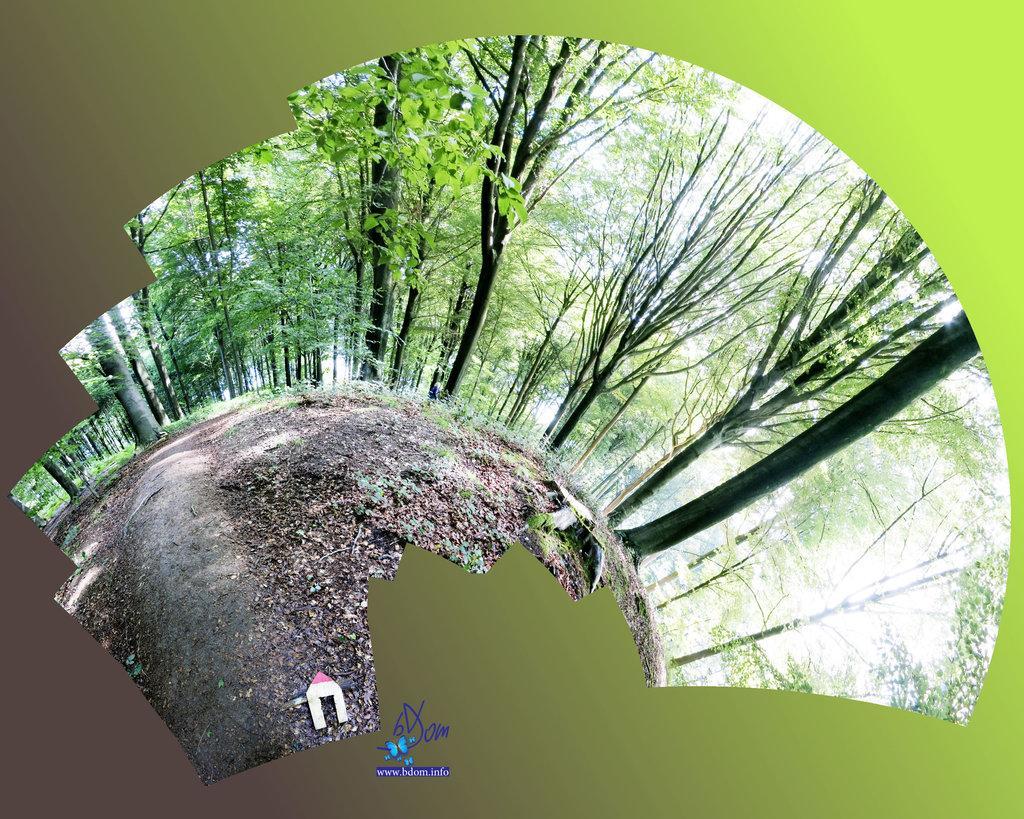Please provide a concise description of this image. In this image we can see the trees everywhere on the ground and the ground is looking like round. 